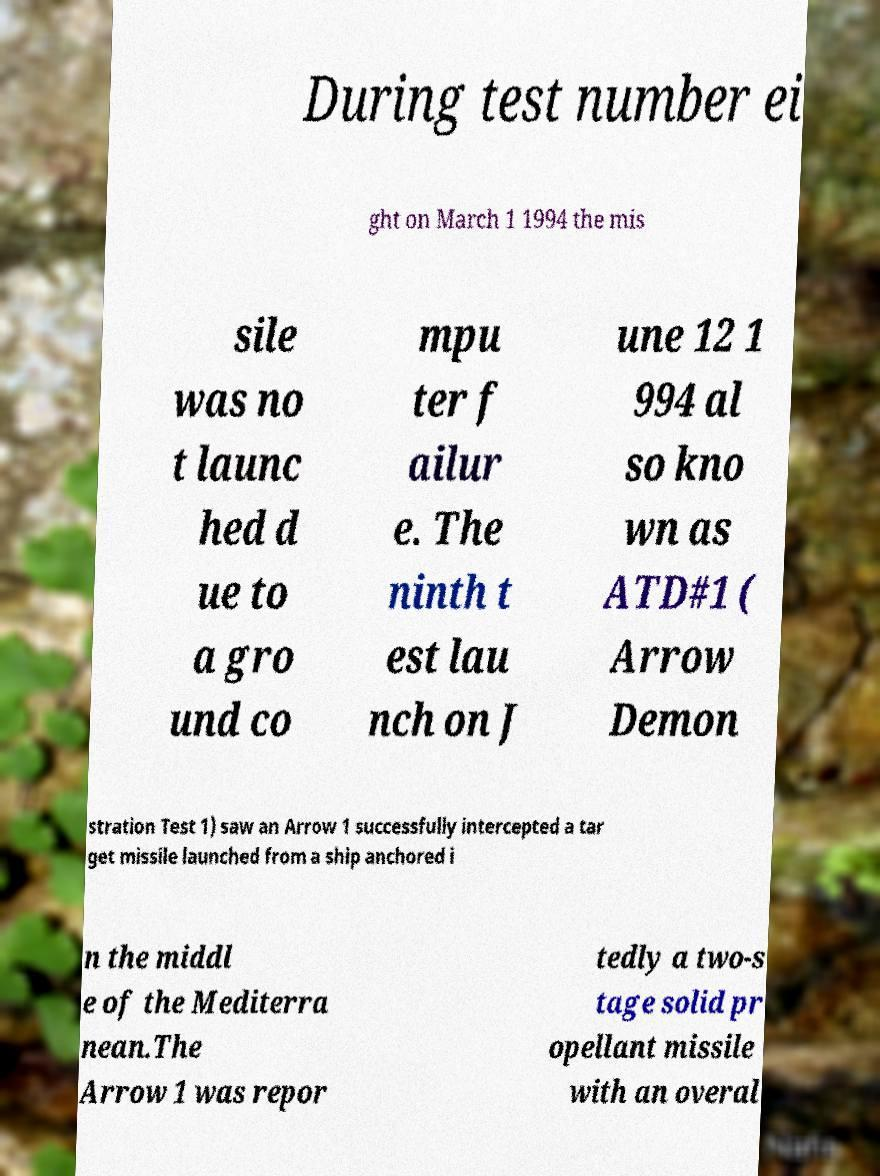Can you accurately transcribe the text from the provided image for me? During test number ei ght on March 1 1994 the mis sile was no t launc hed d ue to a gro und co mpu ter f ailur e. The ninth t est lau nch on J une 12 1 994 al so kno wn as ATD#1 ( Arrow Demon stration Test 1) saw an Arrow 1 successfully intercepted a tar get missile launched from a ship anchored i n the middl e of the Mediterra nean.The Arrow 1 was repor tedly a two-s tage solid pr opellant missile with an overal 